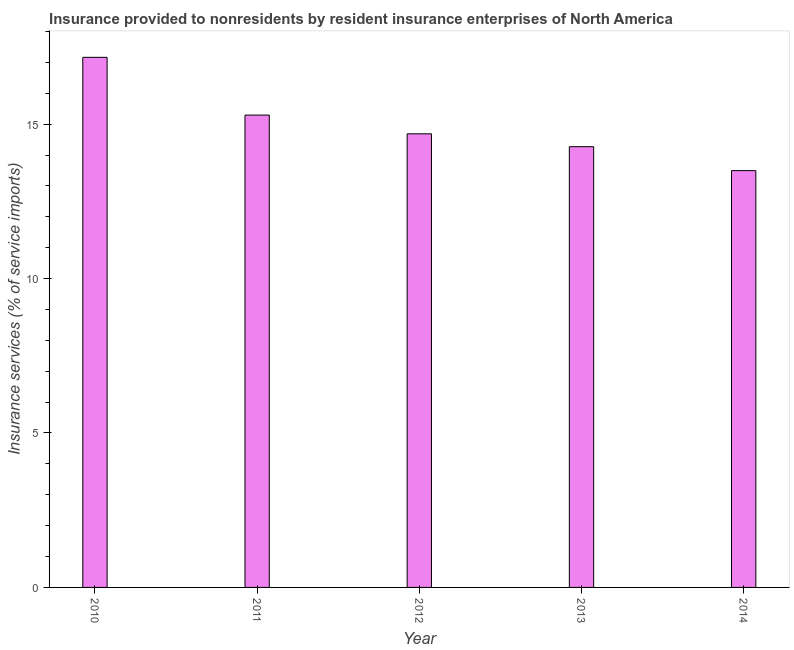Does the graph contain any zero values?
Give a very brief answer. No. What is the title of the graph?
Make the answer very short. Insurance provided to nonresidents by resident insurance enterprises of North America. What is the label or title of the X-axis?
Give a very brief answer. Year. What is the label or title of the Y-axis?
Make the answer very short. Insurance services (% of service imports). What is the insurance and financial services in 2014?
Your answer should be compact. 13.49. Across all years, what is the maximum insurance and financial services?
Offer a terse response. 17.16. Across all years, what is the minimum insurance and financial services?
Offer a terse response. 13.49. In which year was the insurance and financial services minimum?
Your response must be concise. 2014. What is the sum of the insurance and financial services?
Offer a very short reply. 74.91. What is the difference between the insurance and financial services in 2012 and 2014?
Offer a very short reply. 1.19. What is the average insurance and financial services per year?
Provide a succinct answer. 14.98. What is the median insurance and financial services?
Provide a short and direct response. 14.69. Do a majority of the years between 2014 and 2012 (inclusive) have insurance and financial services greater than 13 %?
Give a very brief answer. Yes. What is the ratio of the insurance and financial services in 2010 to that in 2013?
Ensure brevity in your answer.  1.2. Is the insurance and financial services in 2011 less than that in 2012?
Give a very brief answer. No. What is the difference between the highest and the second highest insurance and financial services?
Offer a very short reply. 1.87. Is the sum of the insurance and financial services in 2011 and 2013 greater than the maximum insurance and financial services across all years?
Keep it short and to the point. Yes. What is the difference between the highest and the lowest insurance and financial services?
Your answer should be very brief. 3.67. In how many years, is the insurance and financial services greater than the average insurance and financial services taken over all years?
Provide a succinct answer. 2. How many bars are there?
Your answer should be compact. 5. What is the difference between two consecutive major ticks on the Y-axis?
Provide a short and direct response. 5. Are the values on the major ticks of Y-axis written in scientific E-notation?
Ensure brevity in your answer.  No. What is the Insurance services (% of service imports) of 2010?
Offer a very short reply. 17.16. What is the Insurance services (% of service imports) of 2011?
Your answer should be very brief. 15.29. What is the Insurance services (% of service imports) of 2012?
Give a very brief answer. 14.69. What is the Insurance services (% of service imports) in 2013?
Provide a short and direct response. 14.27. What is the Insurance services (% of service imports) in 2014?
Your response must be concise. 13.49. What is the difference between the Insurance services (% of service imports) in 2010 and 2011?
Provide a succinct answer. 1.87. What is the difference between the Insurance services (% of service imports) in 2010 and 2012?
Give a very brief answer. 2.48. What is the difference between the Insurance services (% of service imports) in 2010 and 2013?
Make the answer very short. 2.89. What is the difference between the Insurance services (% of service imports) in 2010 and 2014?
Your answer should be very brief. 3.67. What is the difference between the Insurance services (% of service imports) in 2011 and 2012?
Keep it short and to the point. 0.61. What is the difference between the Insurance services (% of service imports) in 2011 and 2013?
Your answer should be very brief. 1.02. What is the difference between the Insurance services (% of service imports) in 2011 and 2014?
Give a very brief answer. 1.8. What is the difference between the Insurance services (% of service imports) in 2012 and 2013?
Your answer should be compact. 0.42. What is the difference between the Insurance services (% of service imports) in 2012 and 2014?
Ensure brevity in your answer.  1.19. What is the difference between the Insurance services (% of service imports) in 2013 and 2014?
Provide a succinct answer. 0.77. What is the ratio of the Insurance services (% of service imports) in 2010 to that in 2011?
Ensure brevity in your answer.  1.12. What is the ratio of the Insurance services (% of service imports) in 2010 to that in 2012?
Offer a terse response. 1.17. What is the ratio of the Insurance services (% of service imports) in 2010 to that in 2013?
Offer a terse response. 1.2. What is the ratio of the Insurance services (% of service imports) in 2010 to that in 2014?
Keep it short and to the point. 1.27. What is the ratio of the Insurance services (% of service imports) in 2011 to that in 2012?
Offer a terse response. 1.04. What is the ratio of the Insurance services (% of service imports) in 2011 to that in 2013?
Provide a short and direct response. 1.07. What is the ratio of the Insurance services (% of service imports) in 2011 to that in 2014?
Give a very brief answer. 1.13. What is the ratio of the Insurance services (% of service imports) in 2012 to that in 2014?
Provide a short and direct response. 1.09. What is the ratio of the Insurance services (% of service imports) in 2013 to that in 2014?
Make the answer very short. 1.06. 